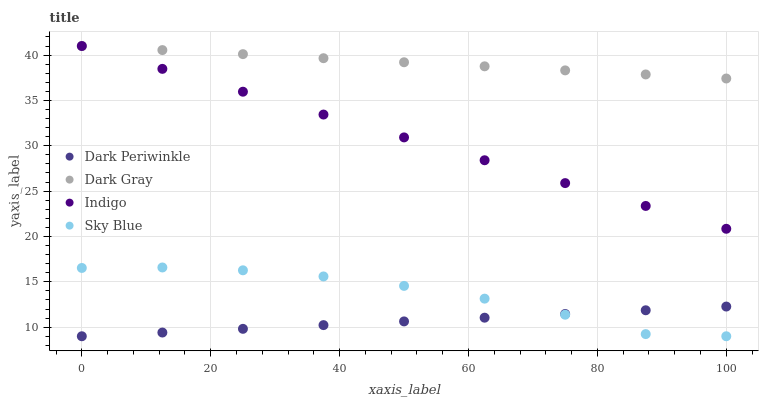Does Dark Periwinkle have the minimum area under the curve?
Answer yes or no. Yes. Does Dark Gray have the maximum area under the curve?
Answer yes or no. Yes. Does Sky Blue have the minimum area under the curve?
Answer yes or no. No. Does Sky Blue have the maximum area under the curve?
Answer yes or no. No. Is Dark Gray the smoothest?
Answer yes or no. Yes. Is Sky Blue the roughest?
Answer yes or no. Yes. Is Indigo the smoothest?
Answer yes or no. No. Is Indigo the roughest?
Answer yes or no. No. Does Sky Blue have the lowest value?
Answer yes or no. Yes. Does Indigo have the lowest value?
Answer yes or no. No. Does Indigo have the highest value?
Answer yes or no. Yes. Does Sky Blue have the highest value?
Answer yes or no. No. Is Dark Periwinkle less than Dark Gray?
Answer yes or no. Yes. Is Indigo greater than Dark Periwinkle?
Answer yes or no. Yes. Does Indigo intersect Dark Gray?
Answer yes or no. Yes. Is Indigo less than Dark Gray?
Answer yes or no. No. Is Indigo greater than Dark Gray?
Answer yes or no. No. Does Dark Periwinkle intersect Dark Gray?
Answer yes or no. No. 